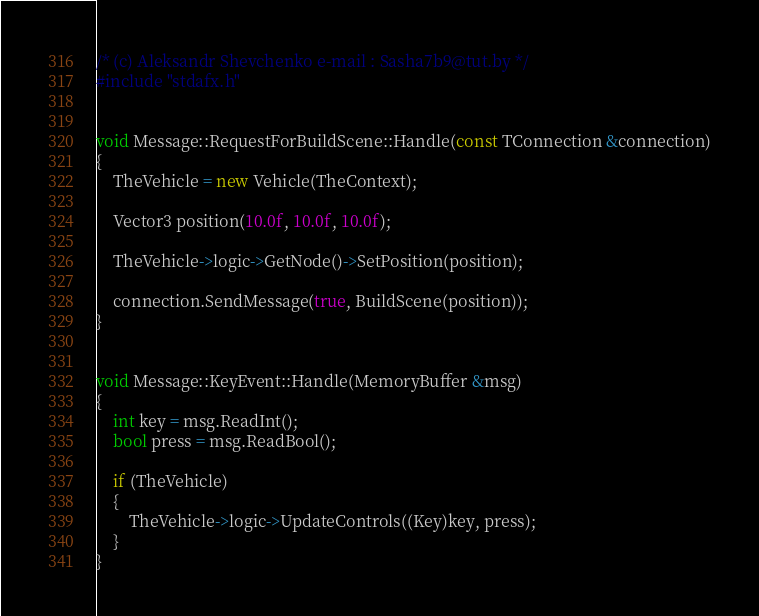<code> <loc_0><loc_0><loc_500><loc_500><_C++_>/* (c) Aleksandr Shevchenko e-mail : Sasha7b9@tut.by */
#include "stdafx.h"


void Message::RequestForBuildScene::Handle(const TConnection &connection)
{
    TheVehicle = new Vehicle(TheContext);

    Vector3 position(10.0f, 10.0f, 10.0f);

    TheVehicle->logic->GetNode()->SetPosition(position);

    connection.SendMessage(true, BuildScene(position));
}


void Message::KeyEvent::Handle(MemoryBuffer &msg)
{
    int key = msg.ReadInt();
    bool press = msg.ReadBool();

    if (TheVehicle)
    {
        TheVehicle->logic->UpdateControls((Key)key, press);
    }
}
</code> 